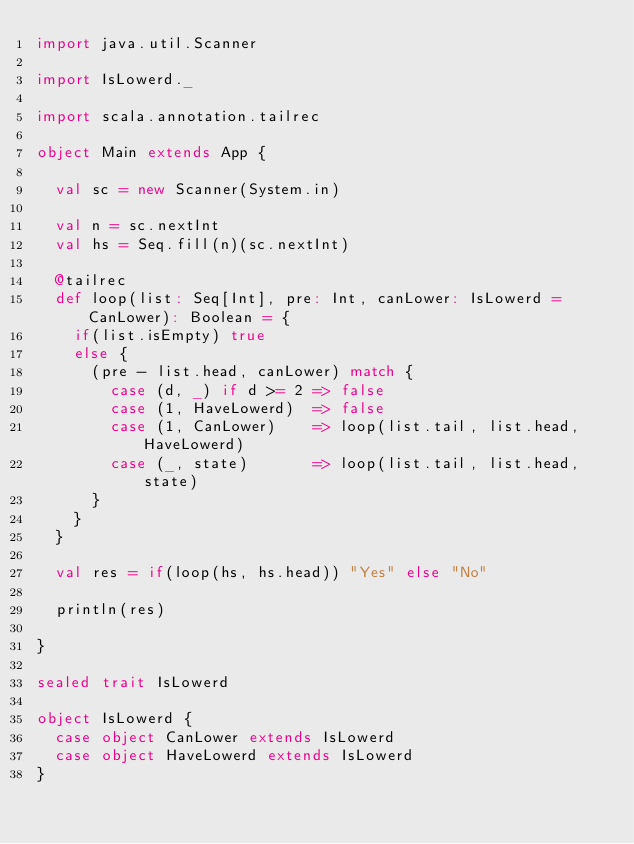Convert code to text. <code><loc_0><loc_0><loc_500><loc_500><_Scala_>import java.util.Scanner

import IsLowerd._

import scala.annotation.tailrec

object Main extends App {

  val sc = new Scanner(System.in)

  val n = sc.nextInt
  val hs = Seq.fill(n)(sc.nextInt)

  @tailrec
  def loop(list: Seq[Int], pre: Int, canLower: IsLowerd = CanLower): Boolean = {
    if(list.isEmpty) true
    else {
      (pre - list.head, canLower) match {
        case (d, _) if d >= 2 => false
        case (1, HaveLowerd)  => false
        case (1, CanLower)    => loop(list.tail, list.head, HaveLowerd)
        case (_, state)       => loop(list.tail, list.head, state)
      }
    }
  }

  val res = if(loop(hs, hs.head)) "Yes" else "No"

  println(res)

}

sealed trait IsLowerd

object IsLowerd {
  case object CanLower extends IsLowerd
  case object HaveLowerd extends IsLowerd
}</code> 